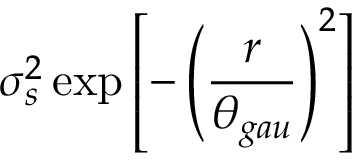<formula> <loc_0><loc_0><loc_500><loc_500>\sigma _ { s } ^ { 2 } \exp \left [ - \left ( \frac { r } { \theta _ { g a u } } \right ) ^ { 2 } \right ]</formula> 